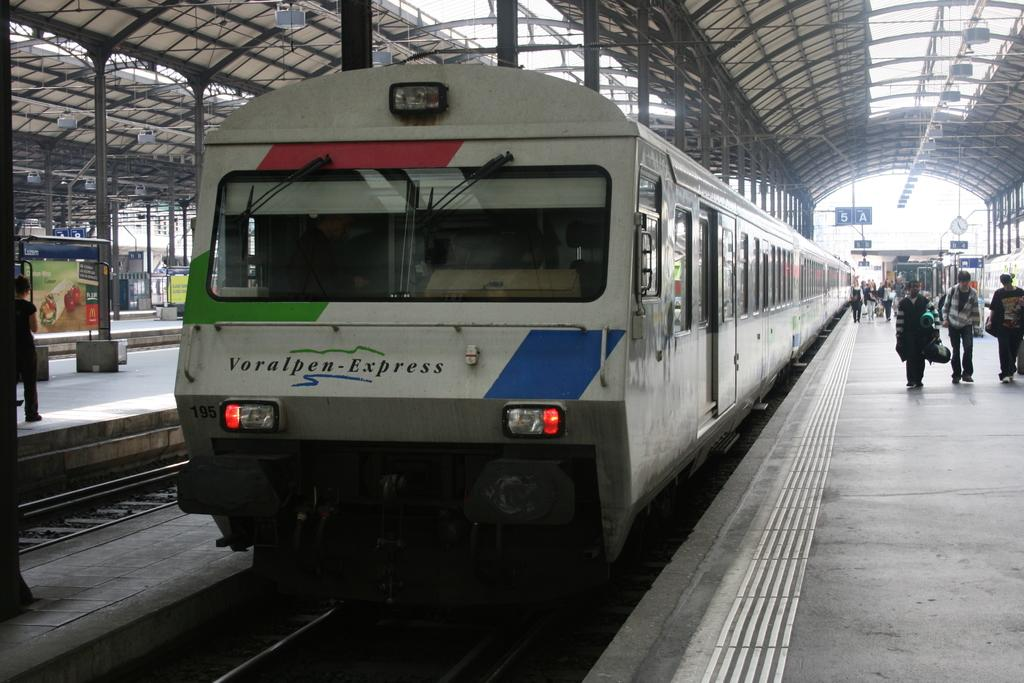<image>
Share a concise interpretation of the image provided. A voralpen-express train has the number 195 next to the left headlight. 